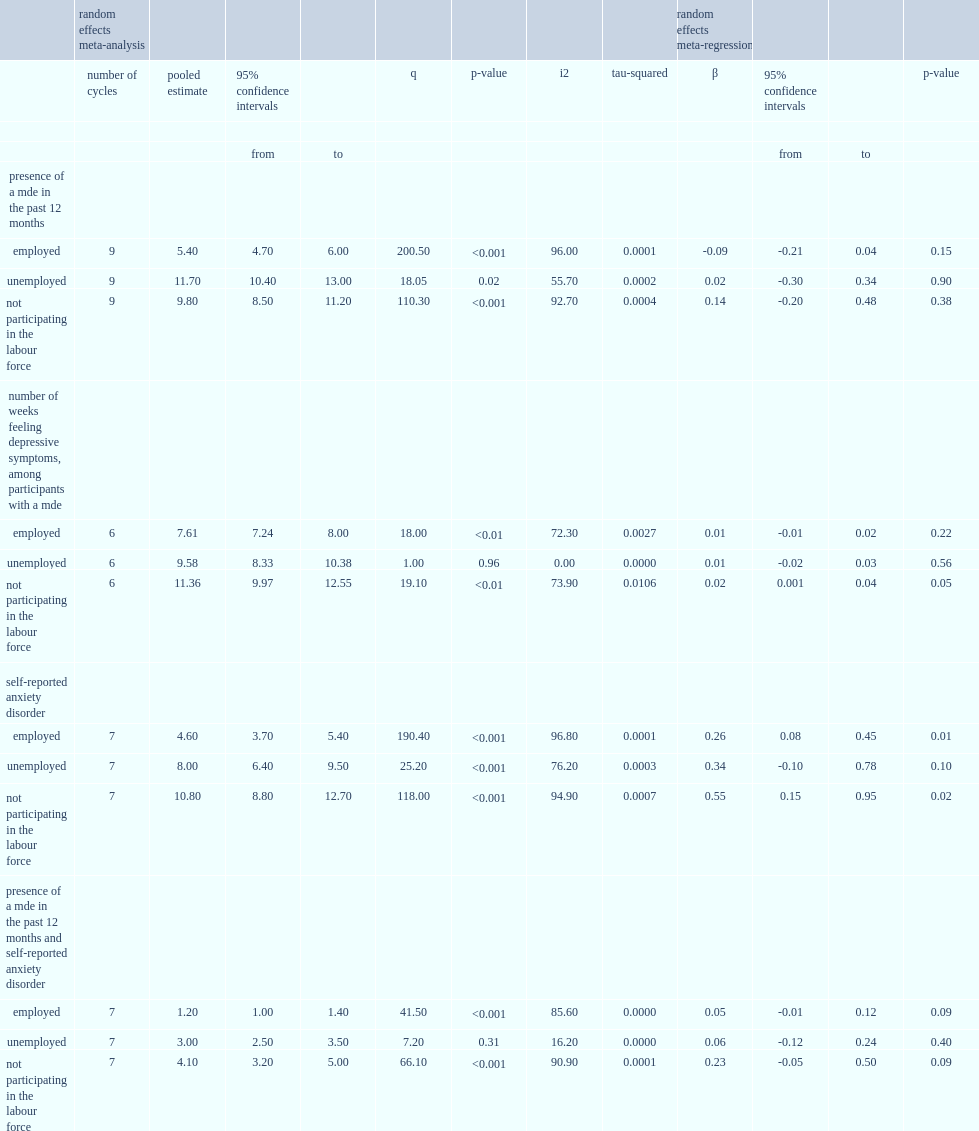How many the average annual mde prevalence was among employed participants? 5.4. How many the average annual mde prevalence was among unemployed participants? 11.7. How many the average annual mde prevalence was among participants not participating in the labour force? 9.8. 